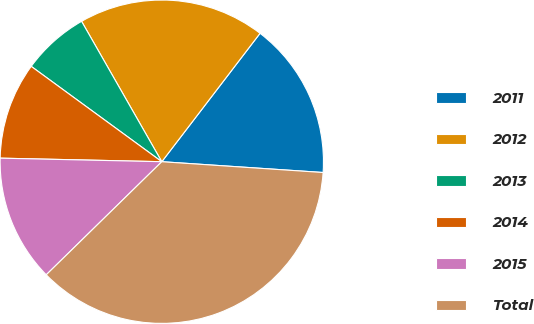<chart> <loc_0><loc_0><loc_500><loc_500><pie_chart><fcel>2011<fcel>2012<fcel>2013<fcel>2014<fcel>2015<fcel>Total<nl><fcel>15.67%<fcel>18.66%<fcel>6.7%<fcel>9.69%<fcel>12.68%<fcel>36.61%<nl></chart> 